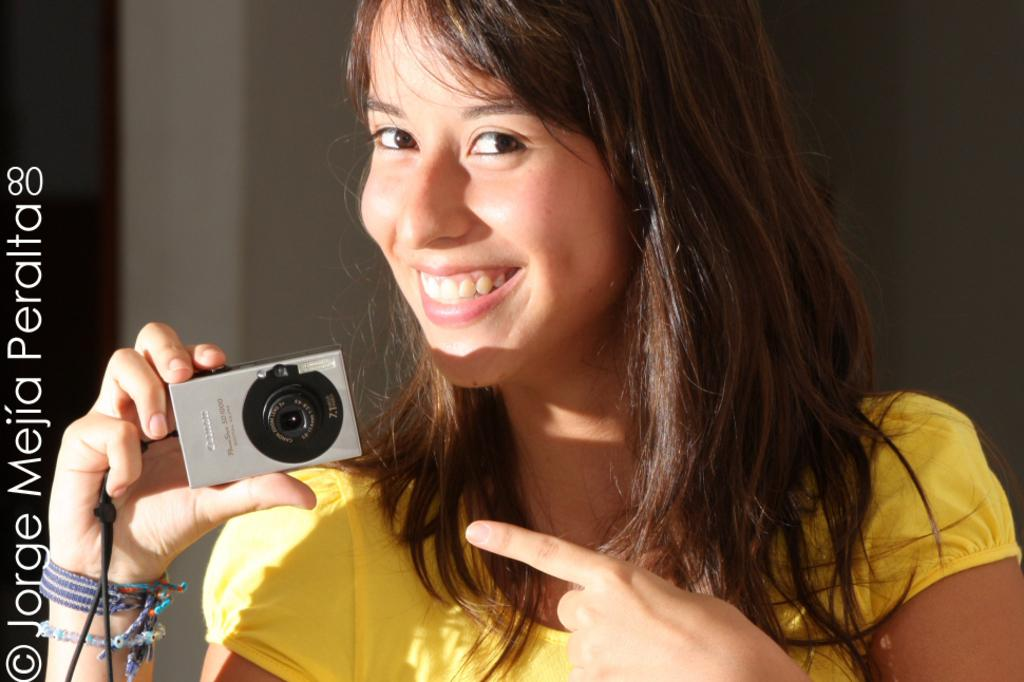Who is the main subject in the image? There is a woman in the image. What is the woman wearing? The woman is wearing a yellow dress. What is the woman holding in the image? The woman is holding a camera. What is the woman's facial expression in the image? The woman is smiling. What can be seen behind the woman in the image? There is a wall behind the woman. Is there any additional information about the image? The image has a watermark. What type of crayon is the woman using to draw on the cloth in the image? There is no crayon or cloth present in the image. What is the boundary of the woman's smile in the image? The question about the boundary of the woman's smile is not relevant, as it is not a measurable or observable aspect of her facial expression. 